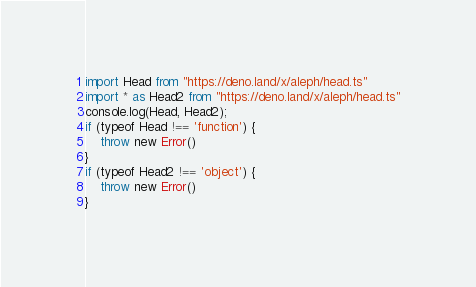Convert code to text. <code><loc_0><loc_0><loc_500><loc_500><_TypeScript_>import Head from "https://deno.land/x/aleph/head.ts"
import * as Head2 from "https://deno.land/x/aleph/head.ts"
console.log(Head, Head2);
if (typeof Head !== 'function') {
    throw new Error()
}
if (typeof Head2 !== 'object') {
    throw new Error()
}</code> 